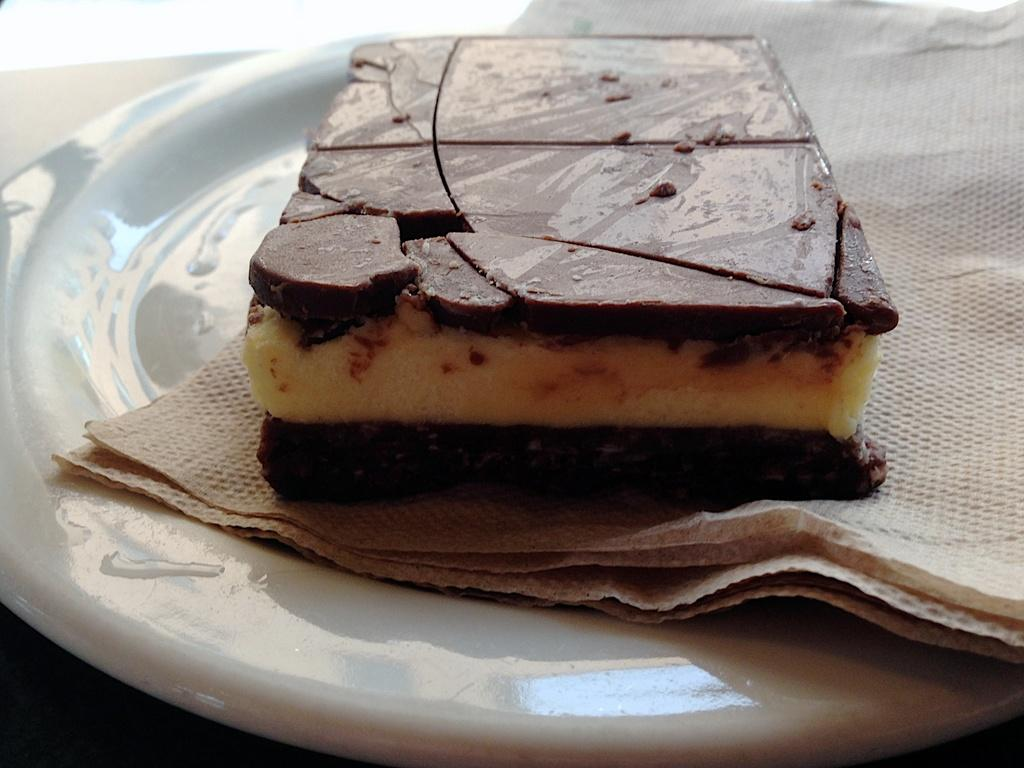What is the main subject of the image? There is a cake in the image. What else can be seen in the image besides the cake? There are paper napkins in the image. Where are the cake and napkins located? The cake and napkins are on a plate. Can you describe the setting of the image? The image might have been taken in a room. How many pages of fiction are included in the image? There are no pages or fiction present in the image; it features a cake and paper napkins on a plate. 